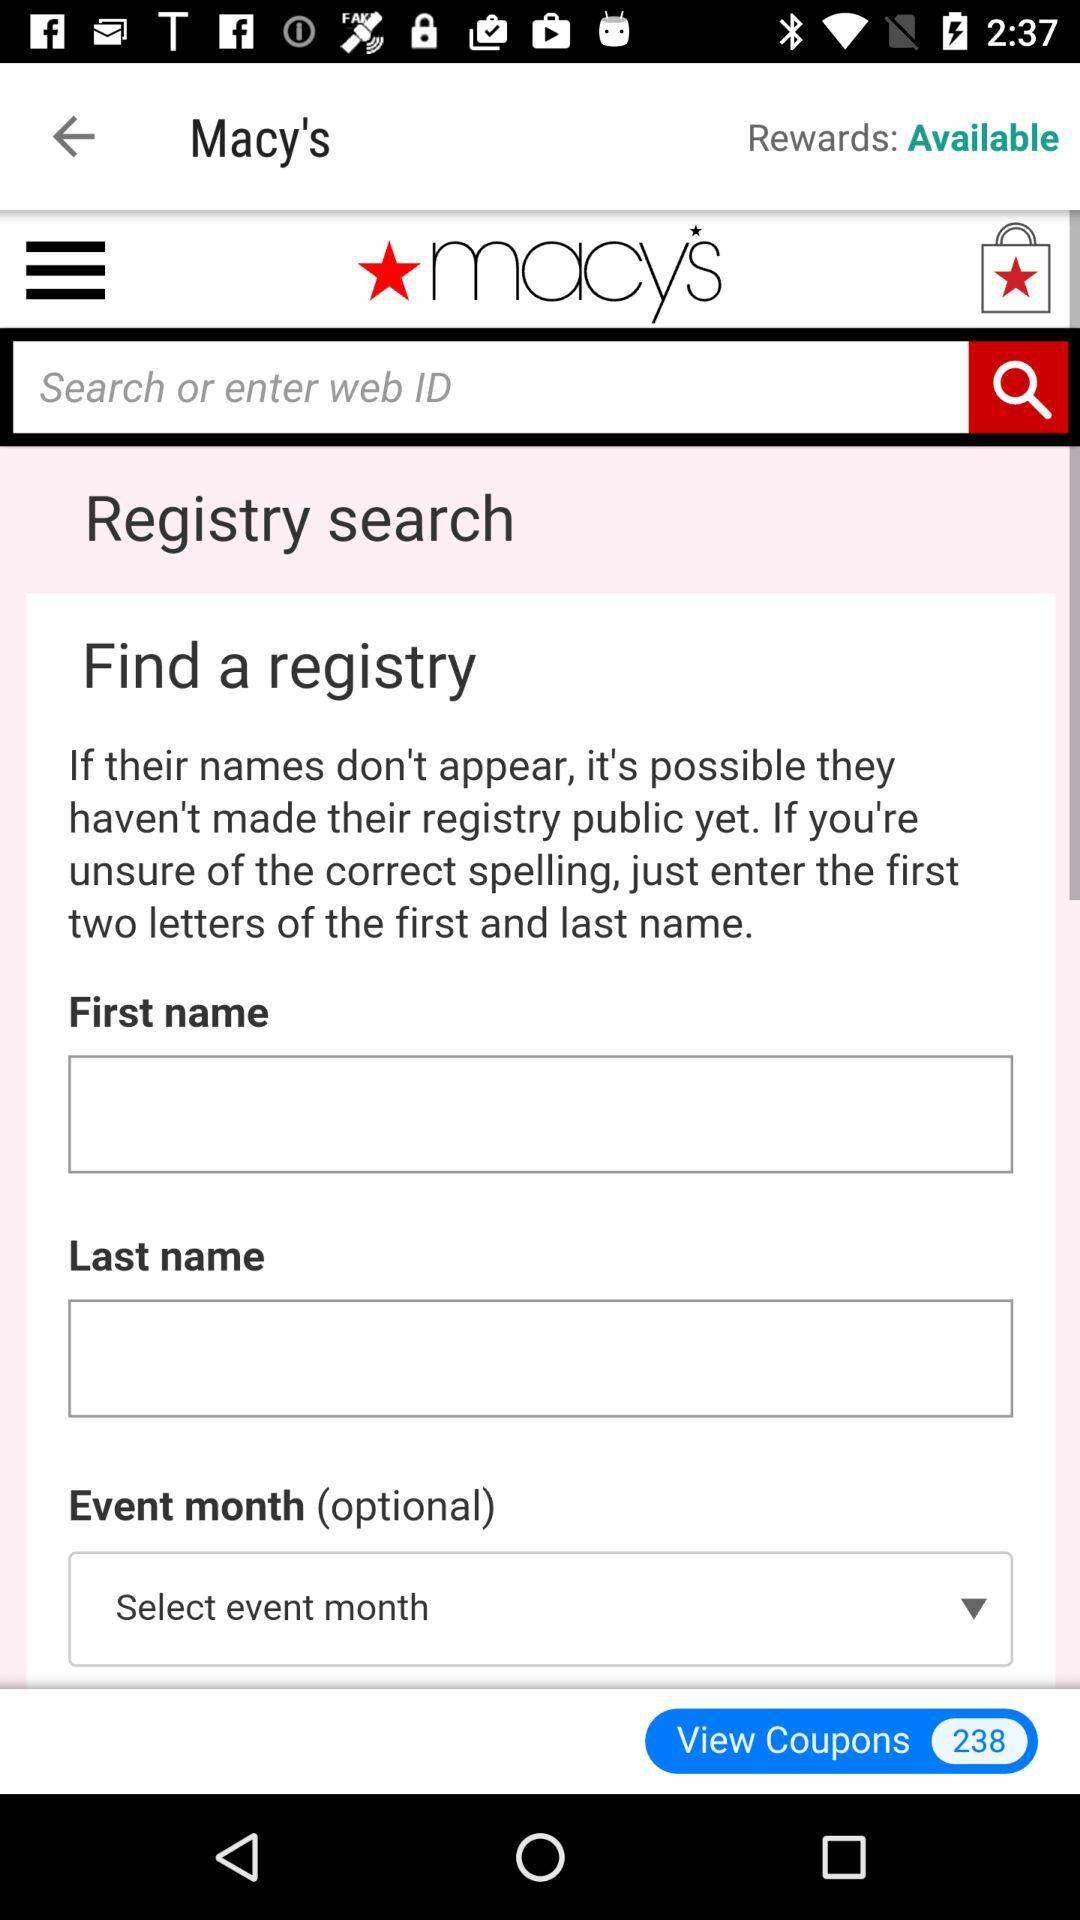What is the current status of the rewards? The current status of the rewards is "Available". 